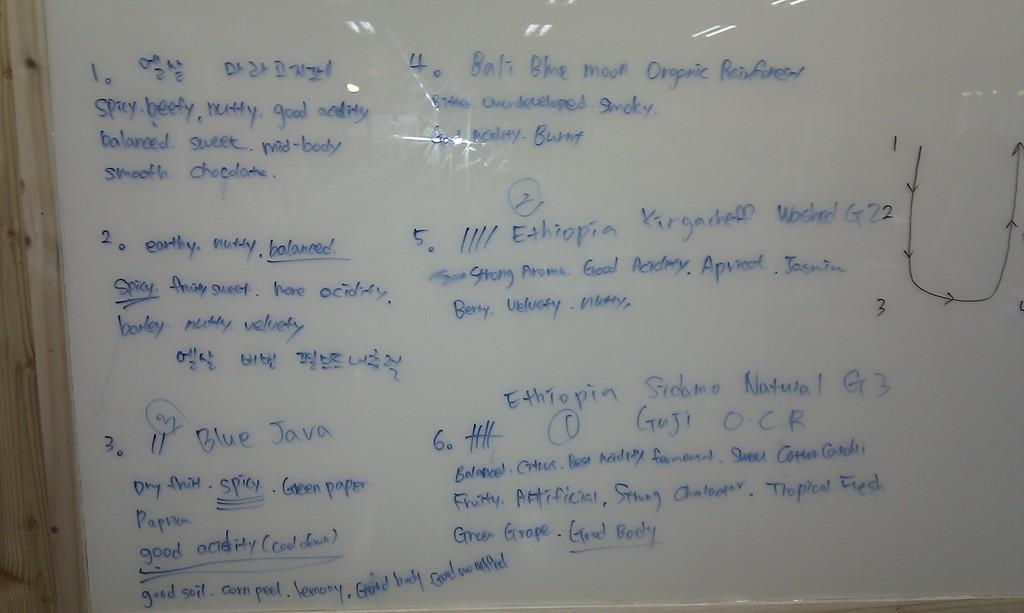<image>
Offer a succinct explanation of the picture presented. A white board detailing various ingredients and descriptions for Ethiopian foods. 